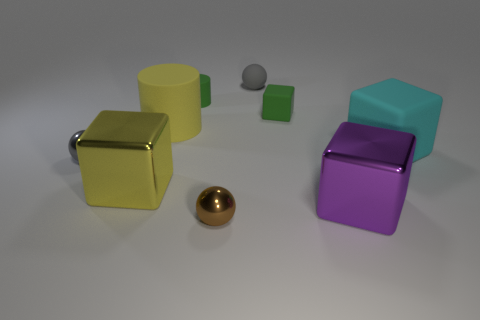Are there fewer small shiny objects than blue things?
Your answer should be compact. No. Are any big purple shiny objects visible?
Your answer should be very brief. Yes. How many other objects are the same size as the matte sphere?
Provide a succinct answer. 4. Are the big cylinder and the gray ball in front of the big matte block made of the same material?
Offer a very short reply. No. Are there an equal number of small matte objects that are left of the gray metal object and large cubes behind the large cylinder?
Give a very brief answer. Yes. What is the green block made of?
Your answer should be compact. Rubber. What color is the rubber sphere that is the same size as the brown metal thing?
Your answer should be compact. Gray. There is a metal ball on the right side of the green rubber cylinder; is there a cyan thing to the right of it?
Provide a succinct answer. Yes. What number of spheres are gray things or large matte objects?
Your response must be concise. 2. What size is the green object on the right side of the tiny gray ball behind the metallic sphere behind the big purple cube?
Provide a succinct answer. Small. 